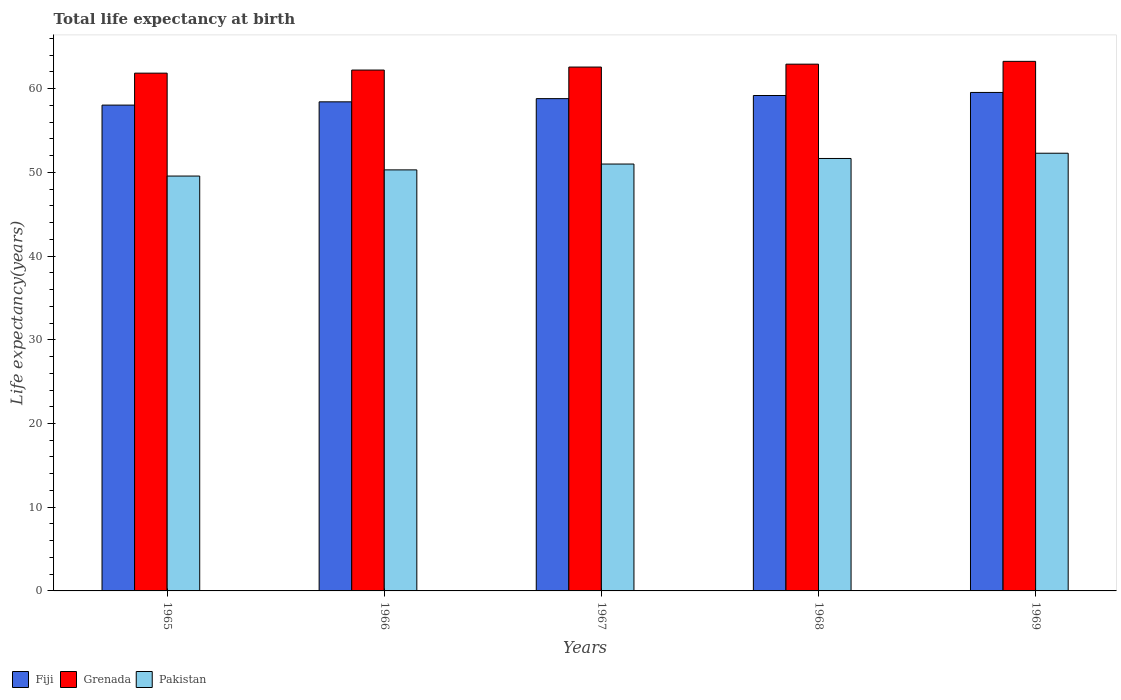How many different coloured bars are there?
Your answer should be very brief. 3. How many groups of bars are there?
Offer a very short reply. 5. How many bars are there on the 3rd tick from the left?
Make the answer very short. 3. What is the label of the 3rd group of bars from the left?
Provide a succinct answer. 1967. What is the life expectancy at birth in in Fiji in 1967?
Provide a short and direct response. 58.81. Across all years, what is the maximum life expectancy at birth in in Fiji?
Provide a short and direct response. 59.55. Across all years, what is the minimum life expectancy at birth in in Grenada?
Your answer should be very brief. 61.85. In which year was the life expectancy at birth in in Fiji maximum?
Your response must be concise. 1969. In which year was the life expectancy at birth in in Fiji minimum?
Provide a succinct answer. 1965. What is the total life expectancy at birth in in Pakistan in the graph?
Offer a very short reply. 254.8. What is the difference between the life expectancy at birth in in Grenada in 1965 and that in 1967?
Give a very brief answer. -0.73. What is the difference between the life expectancy at birth in in Grenada in 1968 and the life expectancy at birth in in Pakistan in 1969?
Offer a very short reply. 10.64. What is the average life expectancy at birth in in Grenada per year?
Keep it short and to the point. 62.57. In the year 1966, what is the difference between the life expectancy at birth in in Fiji and life expectancy at birth in in Grenada?
Make the answer very short. -3.8. In how many years, is the life expectancy at birth in in Pakistan greater than 20 years?
Make the answer very short. 5. What is the ratio of the life expectancy at birth in in Grenada in 1965 to that in 1969?
Your answer should be very brief. 0.98. Is the life expectancy at birth in in Pakistan in 1966 less than that in 1969?
Your answer should be compact. Yes. What is the difference between the highest and the second highest life expectancy at birth in in Grenada?
Provide a short and direct response. 0.34. What is the difference between the highest and the lowest life expectancy at birth in in Pakistan?
Offer a terse response. 2.73. In how many years, is the life expectancy at birth in in Fiji greater than the average life expectancy at birth in in Fiji taken over all years?
Provide a short and direct response. 3. Is the sum of the life expectancy at birth in in Pakistan in 1966 and 1969 greater than the maximum life expectancy at birth in in Grenada across all years?
Your answer should be very brief. Yes. What does the 1st bar from the left in 1969 represents?
Make the answer very short. Fiji. What does the 3rd bar from the right in 1966 represents?
Offer a terse response. Fiji. Are the values on the major ticks of Y-axis written in scientific E-notation?
Your response must be concise. No. Does the graph contain grids?
Provide a short and direct response. No. Where does the legend appear in the graph?
Your response must be concise. Bottom left. How many legend labels are there?
Provide a short and direct response. 3. How are the legend labels stacked?
Provide a short and direct response. Horizontal. What is the title of the graph?
Provide a short and direct response. Total life expectancy at birth. Does "Mexico" appear as one of the legend labels in the graph?
Ensure brevity in your answer.  No. What is the label or title of the Y-axis?
Your answer should be very brief. Life expectancy(years). What is the Life expectancy(years) in Fiji in 1965?
Offer a terse response. 58.04. What is the Life expectancy(years) in Grenada in 1965?
Your answer should be very brief. 61.85. What is the Life expectancy(years) in Pakistan in 1965?
Offer a very short reply. 49.56. What is the Life expectancy(years) of Fiji in 1966?
Offer a very short reply. 58.43. What is the Life expectancy(years) of Grenada in 1966?
Make the answer very short. 62.22. What is the Life expectancy(years) in Pakistan in 1966?
Offer a terse response. 50.3. What is the Life expectancy(years) of Fiji in 1967?
Keep it short and to the point. 58.81. What is the Life expectancy(years) in Grenada in 1967?
Your answer should be very brief. 62.58. What is the Life expectancy(years) of Pakistan in 1967?
Provide a succinct answer. 51. What is the Life expectancy(years) in Fiji in 1968?
Give a very brief answer. 59.18. What is the Life expectancy(years) of Grenada in 1968?
Your answer should be very brief. 62.93. What is the Life expectancy(years) of Pakistan in 1968?
Your answer should be compact. 51.66. What is the Life expectancy(years) of Fiji in 1969?
Offer a terse response. 59.55. What is the Life expectancy(years) in Grenada in 1969?
Provide a short and direct response. 63.26. What is the Life expectancy(years) of Pakistan in 1969?
Keep it short and to the point. 52.29. Across all years, what is the maximum Life expectancy(years) of Fiji?
Make the answer very short. 59.55. Across all years, what is the maximum Life expectancy(years) of Grenada?
Ensure brevity in your answer.  63.26. Across all years, what is the maximum Life expectancy(years) of Pakistan?
Ensure brevity in your answer.  52.29. Across all years, what is the minimum Life expectancy(years) of Fiji?
Make the answer very short. 58.04. Across all years, what is the minimum Life expectancy(years) in Grenada?
Provide a short and direct response. 61.85. Across all years, what is the minimum Life expectancy(years) of Pakistan?
Offer a very short reply. 49.56. What is the total Life expectancy(years) in Fiji in the graph?
Your answer should be very brief. 294. What is the total Life expectancy(years) of Grenada in the graph?
Offer a very short reply. 312.85. What is the total Life expectancy(years) of Pakistan in the graph?
Offer a very short reply. 254.8. What is the difference between the Life expectancy(years) in Fiji in 1965 and that in 1966?
Your answer should be very brief. -0.39. What is the difference between the Life expectancy(years) in Grenada in 1965 and that in 1966?
Your answer should be compact. -0.37. What is the difference between the Life expectancy(years) in Pakistan in 1965 and that in 1966?
Provide a succinct answer. -0.74. What is the difference between the Life expectancy(years) of Fiji in 1965 and that in 1967?
Give a very brief answer. -0.77. What is the difference between the Life expectancy(years) in Grenada in 1965 and that in 1967?
Your answer should be very brief. -0.73. What is the difference between the Life expectancy(years) of Pakistan in 1965 and that in 1967?
Keep it short and to the point. -1.44. What is the difference between the Life expectancy(years) of Fiji in 1965 and that in 1968?
Offer a very short reply. -1.15. What is the difference between the Life expectancy(years) in Grenada in 1965 and that in 1968?
Provide a succinct answer. -1.07. What is the difference between the Life expectancy(years) in Pakistan in 1965 and that in 1968?
Your answer should be very brief. -2.1. What is the difference between the Life expectancy(years) in Fiji in 1965 and that in 1969?
Provide a short and direct response. -1.51. What is the difference between the Life expectancy(years) of Grenada in 1965 and that in 1969?
Offer a very short reply. -1.41. What is the difference between the Life expectancy(years) in Pakistan in 1965 and that in 1969?
Your answer should be compact. -2.73. What is the difference between the Life expectancy(years) of Fiji in 1966 and that in 1967?
Provide a short and direct response. -0.38. What is the difference between the Life expectancy(years) of Grenada in 1966 and that in 1967?
Make the answer very short. -0.36. What is the difference between the Life expectancy(years) in Pakistan in 1966 and that in 1967?
Provide a short and direct response. -0.7. What is the difference between the Life expectancy(years) of Fiji in 1966 and that in 1968?
Make the answer very short. -0.76. What is the difference between the Life expectancy(years) of Grenada in 1966 and that in 1968?
Provide a short and direct response. -0.7. What is the difference between the Life expectancy(years) in Pakistan in 1966 and that in 1968?
Provide a short and direct response. -1.36. What is the difference between the Life expectancy(years) in Fiji in 1966 and that in 1969?
Offer a very short reply. -1.12. What is the difference between the Life expectancy(years) of Grenada in 1966 and that in 1969?
Provide a succinct answer. -1.04. What is the difference between the Life expectancy(years) of Pakistan in 1966 and that in 1969?
Ensure brevity in your answer.  -1.99. What is the difference between the Life expectancy(years) of Fiji in 1967 and that in 1968?
Your response must be concise. -0.37. What is the difference between the Life expectancy(years) of Grenada in 1967 and that in 1968?
Give a very brief answer. -0.35. What is the difference between the Life expectancy(years) in Pakistan in 1967 and that in 1968?
Your answer should be compact. -0.66. What is the difference between the Life expectancy(years) in Fiji in 1967 and that in 1969?
Offer a terse response. -0.74. What is the difference between the Life expectancy(years) in Grenada in 1967 and that in 1969?
Your answer should be compact. -0.68. What is the difference between the Life expectancy(years) of Pakistan in 1967 and that in 1969?
Your answer should be very brief. -1.29. What is the difference between the Life expectancy(years) of Fiji in 1968 and that in 1969?
Offer a terse response. -0.37. What is the difference between the Life expectancy(years) in Grenada in 1968 and that in 1969?
Your answer should be very brief. -0.34. What is the difference between the Life expectancy(years) of Pakistan in 1968 and that in 1969?
Ensure brevity in your answer.  -0.63. What is the difference between the Life expectancy(years) in Fiji in 1965 and the Life expectancy(years) in Grenada in 1966?
Give a very brief answer. -4.19. What is the difference between the Life expectancy(years) of Fiji in 1965 and the Life expectancy(years) of Pakistan in 1966?
Your answer should be very brief. 7.74. What is the difference between the Life expectancy(years) of Grenada in 1965 and the Life expectancy(years) of Pakistan in 1966?
Your answer should be compact. 11.56. What is the difference between the Life expectancy(years) in Fiji in 1965 and the Life expectancy(years) in Grenada in 1967?
Give a very brief answer. -4.54. What is the difference between the Life expectancy(years) in Fiji in 1965 and the Life expectancy(years) in Pakistan in 1967?
Give a very brief answer. 7.04. What is the difference between the Life expectancy(years) of Grenada in 1965 and the Life expectancy(years) of Pakistan in 1967?
Provide a short and direct response. 10.86. What is the difference between the Life expectancy(years) in Fiji in 1965 and the Life expectancy(years) in Grenada in 1968?
Provide a short and direct response. -4.89. What is the difference between the Life expectancy(years) of Fiji in 1965 and the Life expectancy(years) of Pakistan in 1968?
Your answer should be very brief. 6.38. What is the difference between the Life expectancy(years) in Grenada in 1965 and the Life expectancy(years) in Pakistan in 1968?
Your answer should be very brief. 10.19. What is the difference between the Life expectancy(years) in Fiji in 1965 and the Life expectancy(years) in Grenada in 1969?
Offer a terse response. -5.23. What is the difference between the Life expectancy(years) of Fiji in 1965 and the Life expectancy(years) of Pakistan in 1969?
Ensure brevity in your answer.  5.75. What is the difference between the Life expectancy(years) of Grenada in 1965 and the Life expectancy(years) of Pakistan in 1969?
Provide a short and direct response. 9.57. What is the difference between the Life expectancy(years) in Fiji in 1966 and the Life expectancy(years) in Grenada in 1967?
Ensure brevity in your answer.  -4.15. What is the difference between the Life expectancy(years) of Fiji in 1966 and the Life expectancy(years) of Pakistan in 1967?
Make the answer very short. 7.43. What is the difference between the Life expectancy(years) of Grenada in 1966 and the Life expectancy(years) of Pakistan in 1967?
Offer a very short reply. 11.23. What is the difference between the Life expectancy(years) in Fiji in 1966 and the Life expectancy(years) in Grenada in 1968?
Offer a terse response. -4.5. What is the difference between the Life expectancy(years) in Fiji in 1966 and the Life expectancy(years) in Pakistan in 1968?
Give a very brief answer. 6.77. What is the difference between the Life expectancy(years) of Grenada in 1966 and the Life expectancy(years) of Pakistan in 1968?
Provide a succinct answer. 10.56. What is the difference between the Life expectancy(years) in Fiji in 1966 and the Life expectancy(years) in Grenada in 1969?
Offer a very short reply. -4.84. What is the difference between the Life expectancy(years) of Fiji in 1966 and the Life expectancy(years) of Pakistan in 1969?
Your answer should be very brief. 6.14. What is the difference between the Life expectancy(years) in Grenada in 1966 and the Life expectancy(years) in Pakistan in 1969?
Your response must be concise. 9.94. What is the difference between the Life expectancy(years) of Fiji in 1967 and the Life expectancy(years) of Grenada in 1968?
Provide a short and direct response. -4.12. What is the difference between the Life expectancy(years) in Fiji in 1967 and the Life expectancy(years) in Pakistan in 1968?
Offer a very short reply. 7.15. What is the difference between the Life expectancy(years) of Grenada in 1967 and the Life expectancy(years) of Pakistan in 1968?
Offer a very short reply. 10.92. What is the difference between the Life expectancy(years) in Fiji in 1967 and the Life expectancy(years) in Grenada in 1969?
Your answer should be very brief. -4.45. What is the difference between the Life expectancy(years) in Fiji in 1967 and the Life expectancy(years) in Pakistan in 1969?
Your answer should be very brief. 6.52. What is the difference between the Life expectancy(years) of Grenada in 1967 and the Life expectancy(years) of Pakistan in 1969?
Your response must be concise. 10.29. What is the difference between the Life expectancy(years) in Fiji in 1968 and the Life expectancy(years) in Grenada in 1969?
Offer a very short reply. -4.08. What is the difference between the Life expectancy(years) in Fiji in 1968 and the Life expectancy(years) in Pakistan in 1969?
Keep it short and to the point. 6.89. What is the difference between the Life expectancy(years) in Grenada in 1968 and the Life expectancy(years) in Pakistan in 1969?
Provide a succinct answer. 10.64. What is the average Life expectancy(years) in Fiji per year?
Provide a short and direct response. 58.8. What is the average Life expectancy(years) in Grenada per year?
Your answer should be very brief. 62.57. What is the average Life expectancy(years) of Pakistan per year?
Provide a succinct answer. 50.96. In the year 1965, what is the difference between the Life expectancy(years) in Fiji and Life expectancy(years) in Grenada?
Ensure brevity in your answer.  -3.82. In the year 1965, what is the difference between the Life expectancy(years) in Fiji and Life expectancy(years) in Pakistan?
Keep it short and to the point. 8.48. In the year 1965, what is the difference between the Life expectancy(years) in Grenada and Life expectancy(years) in Pakistan?
Provide a short and direct response. 12.29. In the year 1966, what is the difference between the Life expectancy(years) in Fiji and Life expectancy(years) in Grenada?
Give a very brief answer. -3.8. In the year 1966, what is the difference between the Life expectancy(years) in Fiji and Life expectancy(years) in Pakistan?
Provide a succinct answer. 8.13. In the year 1966, what is the difference between the Life expectancy(years) of Grenada and Life expectancy(years) of Pakistan?
Make the answer very short. 11.93. In the year 1967, what is the difference between the Life expectancy(years) in Fiji and Life expectancy(years) in Grenada?
Your response must be concise. -3.77. In the year 1967, what is the difference between the Life expectancy(years) of Fiji and Life expectancy(years) of Pakistan?
Provide a short and direct response. 7.81. In the year 1967, what is the difference between the Life expectancy(years) of Grenada and Life expectancy(years) of Pakistan?
Your answer should be compact. 11.58. In the year 1968, what is the difference between the Life expectancy(years) in Fiji and Life expectancy(years) in Grenada?
Your response must be concise. -3.74. In the year 1968, what is the difference between the Life expectancy(years) in Fiji and Life expectancy(years) in Pakistan?
Ensure brevity in your answer.  7.52. In the year 1968, what is the difference between the Life expectancy(years) of Grenada and Life expectancy(years) of Pakistan?
Give a very brief answer. 11.27. In the year 1969, what is the difference between the Life expectancy(years) of Fiji and Life expectancy(years) of Grenada?
Provide a succinct answer. -3.71. In the year 1969, what is the difference between the Life expectancy(years) of Fiji and Life expectancy(years) of Pakistan?
Provide a succinct answer. 7.26. In the year 1969, what is the difference between the Life expectancy(years) of Grenada and Life expectancy(years) of Pakistan?
Your answer should be very brief. 10.97. What is the ratio of the Life expectancy(years) of Fiji in 1965 to that in 1966?
Offer a terse response. 0.99. What is the ratio of the Life expectancy(years) in Grenada in 1965 to that in 1966?
Ensure brevity in your answer.  0.99. What is the ratio of the Life expectancy(years) of Pakistan in 1965 to that in 1966?
Offer a very short reply. 0.99. What is the ratio of the Life expectancy(years) of Fiji in 1965 to that in 1967?
Give a very brief answer. 0.99. What is the ratio of the Life expectancy(years) of Grenada in 1965 to that in 1967?
Offer a terse response. 0.99. What is the ratio of the Life expectancy(years) of Pakistan in 1965 to that in 1967?
Your answer should be compact. 0.97. What is the ratio of the Life expectancy(years) of Fiji in 1965 to that in 1968?
Provide a short and direct response. 0.98. What is the ratio of the Life expectancy(years) in Grenada in 1965 to that in 1968?
Provide a succinct answer. 0.98. What is the ratio of the Life expectancy(years) of Pakistan in 1965 to that in 1968?
Your answer should be very brief. 0.96. What is the ratio of the Life expectancy(years) in Fiji in 1965 to that in 1969?
Provide a short and direct response. 0.97. What is the ratio of the Life expectancy(years) in Grenada in 1965 to that in 1969?
Keep it short and to the point. 0.98. What is the ratio of the Life expectancy(years) in Pakistan in 1965 to that in 1969?
Ensure brevity in your answer.  0.95. What is the ratio of the Life expectancy(years) in Pakistan in 1966 to that in 1967?
Provide a short and direct response. 0.99. What is the ratio of the Life expectancy(years) in Fiji in 1966 to that in 1968?
Give a very brief answer. 0.99. What is the ratio of the Life expectancy(years) of Grenada in 1966 to that in 1968?
Your answer should be very brief. 0.99. What is the ratio of the Life expectancy(years) in Pakistan in 1966 to that in 1968?
Your response must be concise. 0.97. What is the ratio of the Life expectancy(years) of Fiji in 1966 to that in 1969?
Ensure brevity in your answer.  0.98. What is the ratio of the Life expectancy(years) of Grenada in 1966 to that in 1969?
Your response must be concise. 0.98. What is the ratio of the Life expectancy(years) of Pakistan in 1966 to that in 1969?
Your answer should be compact. 0.96. What is the ratio of the Life expectancy(years) in Fiji in 1967 to that in 1968?
Your answer should be very brief. 0.99. What is the ratio of the Life expectancy(years) of Grenada in 1967 to that in 1968?
Your response must be concise. 0.99. What is the ratio of the Life expectancy(years) in Pakistan in 1967 to that in 1968?
Provide a succinct answer. 0.99. What is the ratio of the Life expectancy(years) in Fiji in 1967 to that in 1969?
Offer a terse response. 0.99. What is the ratio of the Life expectancy(years) in Grenada in 1967 to that in 1969?
Your answer should be very brief. 0.99. What is the ratio of the Life expectancy(years) in Pakistan in 1967 to that in 1969?
Your response must be concise. 0.98. What is the ratio of the Life expectancy(years) of Grenada in 1968 to that in 1969?
Give a very brief answer. 0.99. What is the difference between the highest and the second highest Life expectancy(years) in Fiji?
Provide a succinct answer. 0.37. What is the difference between the highest and the second highest Life expectancy(years) in Grenada?
Keep it short and to the point. 0.34. What is the difference between the highest and the second highest Life expectancy(years) in Pakistan?
Your answer should be compact. 0.63. What is the difference between the highest and the lowest Life expectancy(years) of Fiji?
Keep it short and to the point. 1.51. What is the difference between the highest and the lowest Life expectancy(years) in Grenada?
Your response must be concise. 1.41. What is the difference between the highest and the lowest Life expectancy(years) of Pakistan?
Keep it short and to the point. 2.73. 